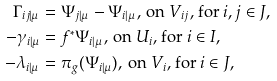Convert formula to latex. <formula><loc_0><loc_0><loc_500><loc_500>\Gamma _ { i j | \mu } & = \Psi _ { j | \mu } - \Psi _ { i | \mu } , \, \text {on $V_{ij}$, for $i,j\in J$} , \\ - \gamma _ { i | \mu } & = f ^ { * } \Psi _ { i | \mu } , \, \text {on $U_{i}$, for $i\in I$} , \\ - \lambda _ { i | \mu } & = \pi _ { g } ( \Psi _ { i | \mu } ) , \, \text {on $V_{i}$, for $i\in J$} ,</formula> 